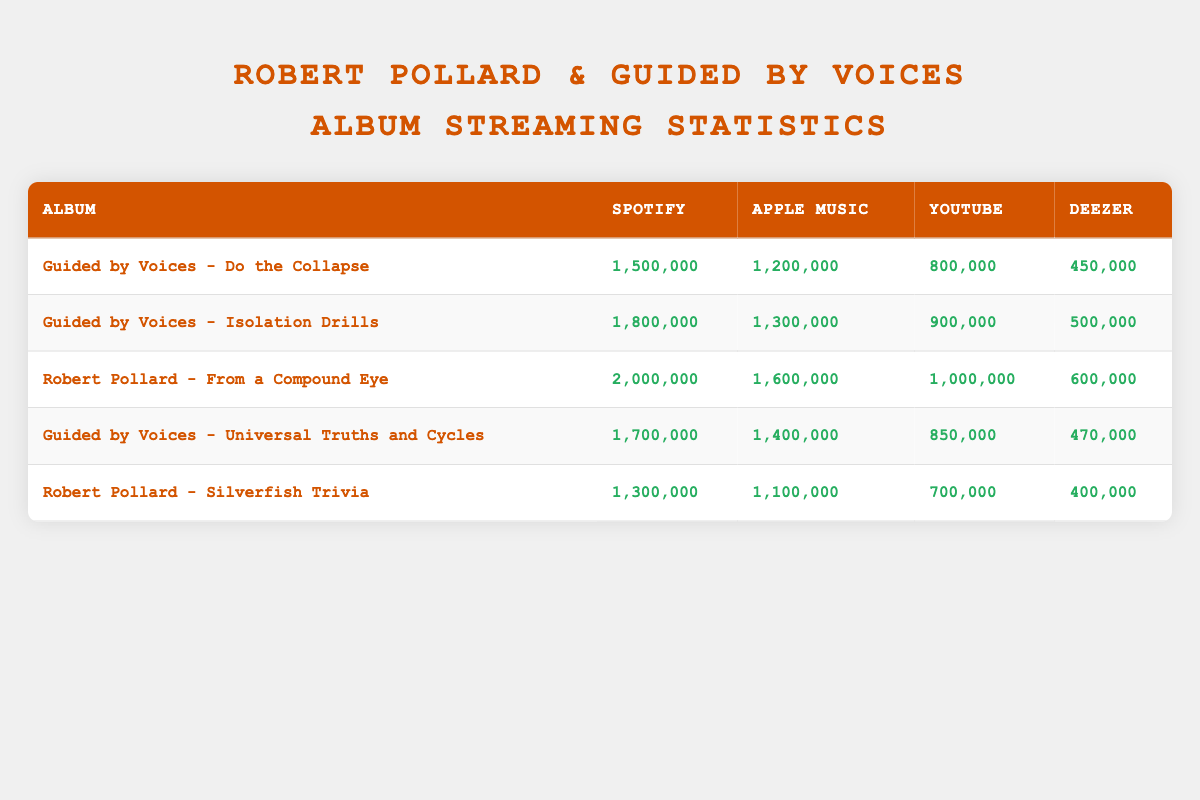What album has the highest number of streams on Spotify? By looking at the Spotify column of the table, we can see that "Robert Pollard - From a Compound Eye" has the highest value of 2,000,000 streams.
Answer: Robert Pollard - From a Compound Eye What is the total number of streams for "Guided by Voices - Do the Collapse" across all platforms? To find the total streams, we add the individual streams: 1,500,000 (Spotify) + 1,200,000 (Apple Music) + 800,000 (YouTube) + 450,000 (Deezer) = 3,950,000.
Answer: 3,950,000 Is "Guided by Voices - Isolation Drills" more popular on YouTube than "Robert Pollard - Silverfish Trivia"? Checking the YouTube streams, "Isolation Drills" has 900,000 streams and "Silverfish Trivia" has 700,000 streams. Since 900,000 is greater than 700,000, the statement is true.
Answer: Yes What is the difference in Apple Music streams between "Guided by Voices - Universal Truths and Cycles" and "Guided by Voices - Do the Collapse"? To find the difference, we subtract the Apple Music streams of "Do the Collapse" (1,200,000) from "Universal Truths and Cycles" (1,400,000): 1,400,000 - 1,200,000 = 200,000.
Answer: 200,000 Which album has the lowest total streaming across all platforms? First, we calculate the total streams for each album. After calculating, we see that "Robert Pollard - Silverfish Trivia" has the lowest total streams of 3,500,000.
Answer: Robert Pollard - Silverfish Trivia 